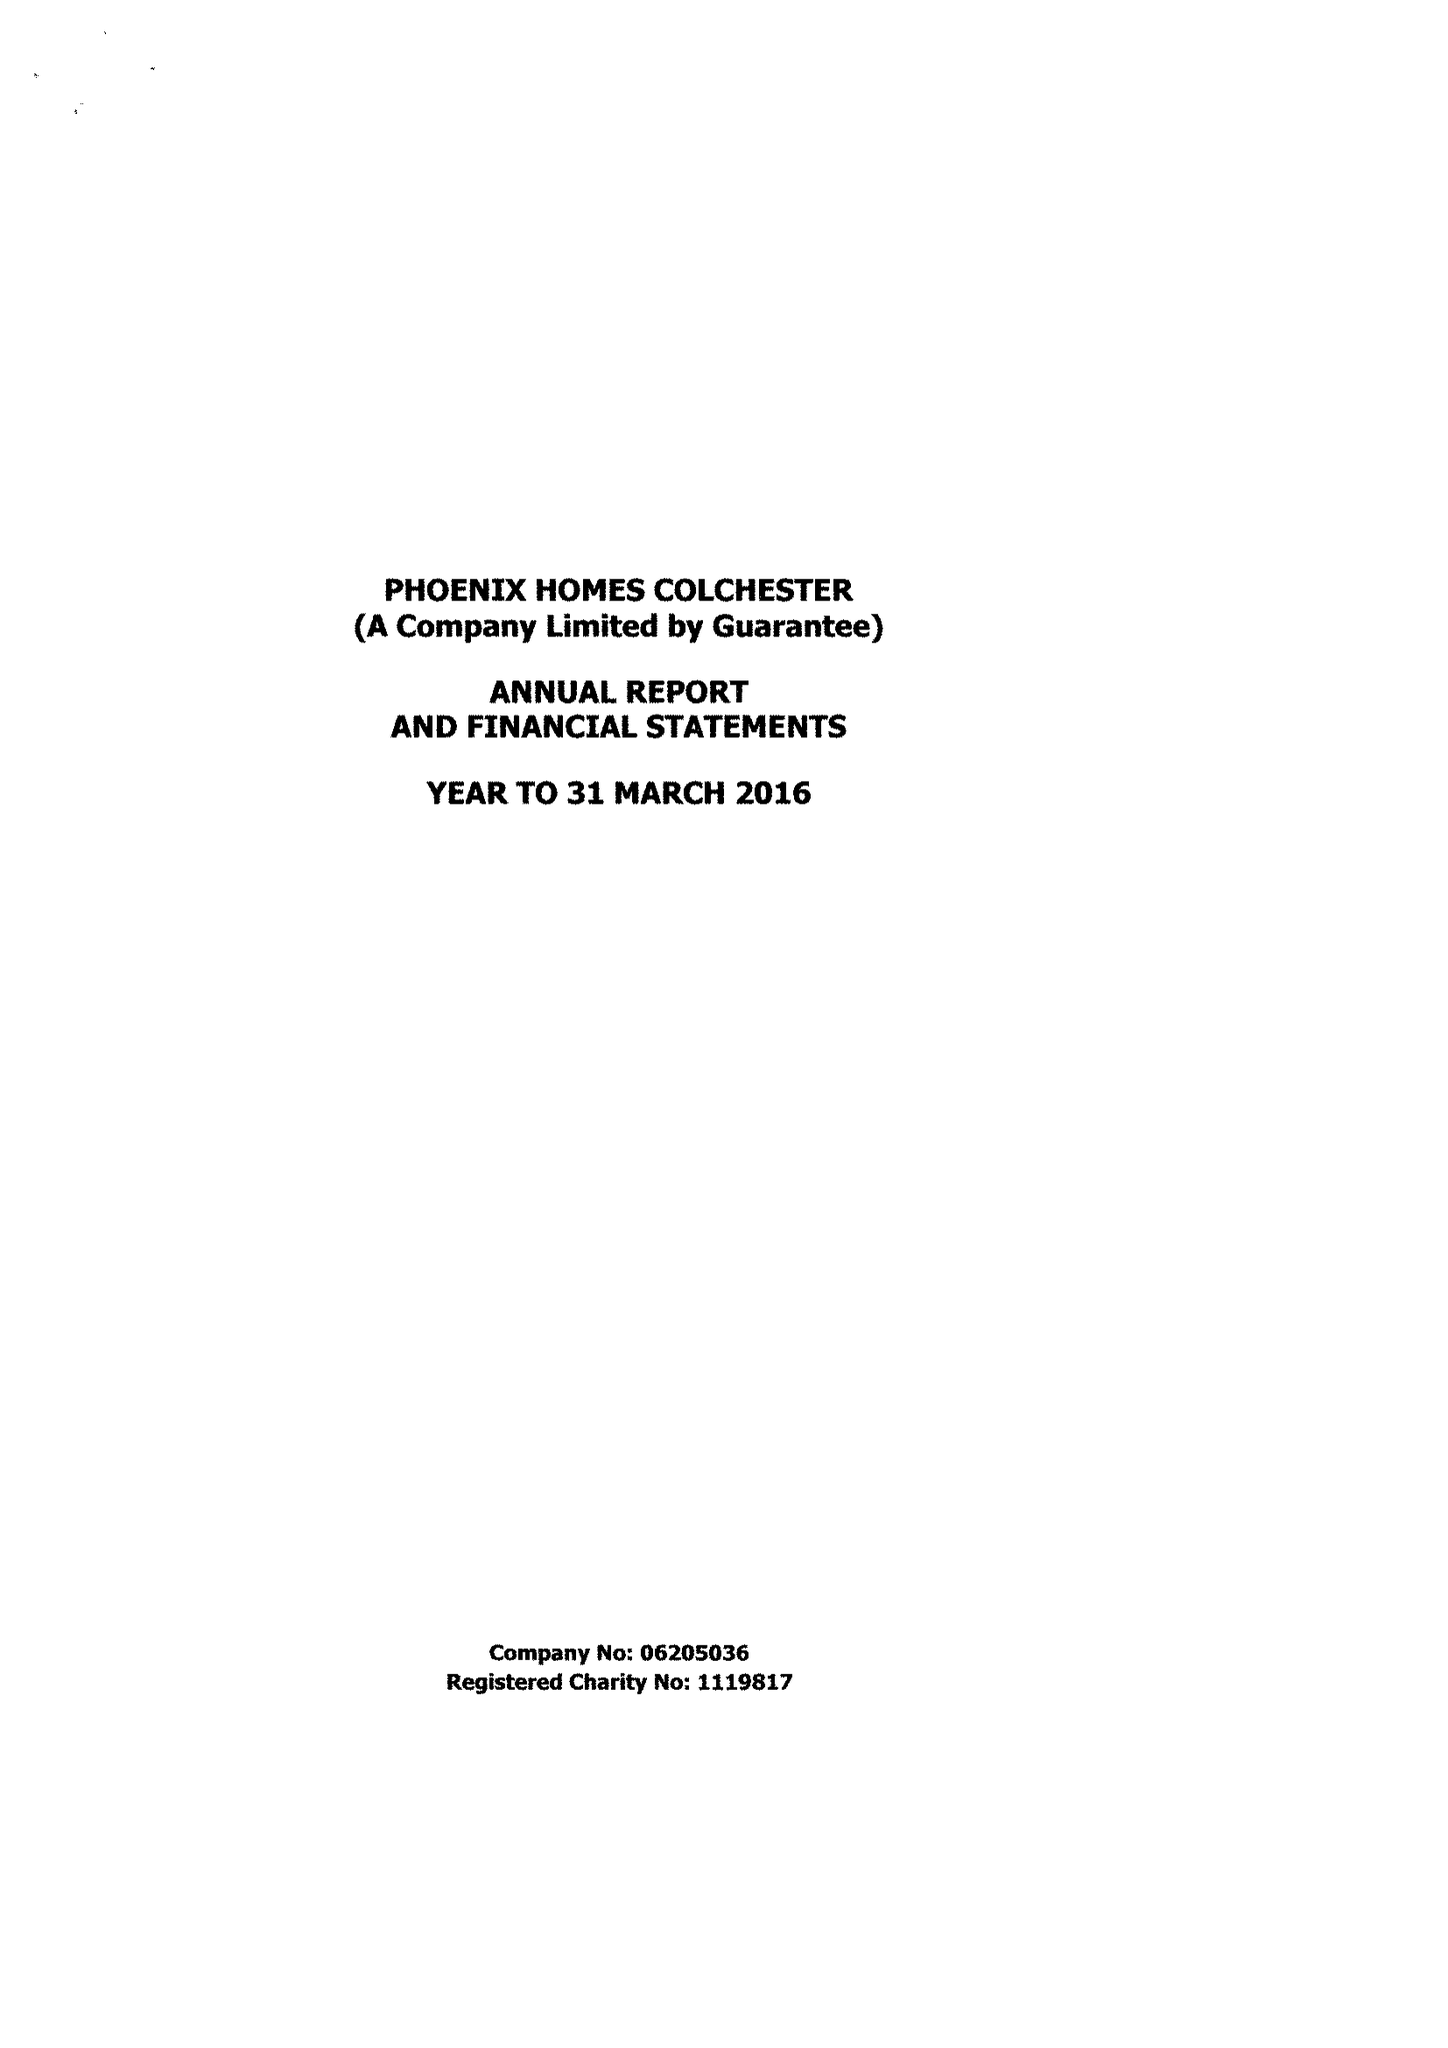What is the value for the income_annually_in_british_pounds?
Answer the question using a single word or phrase. 391611.00 